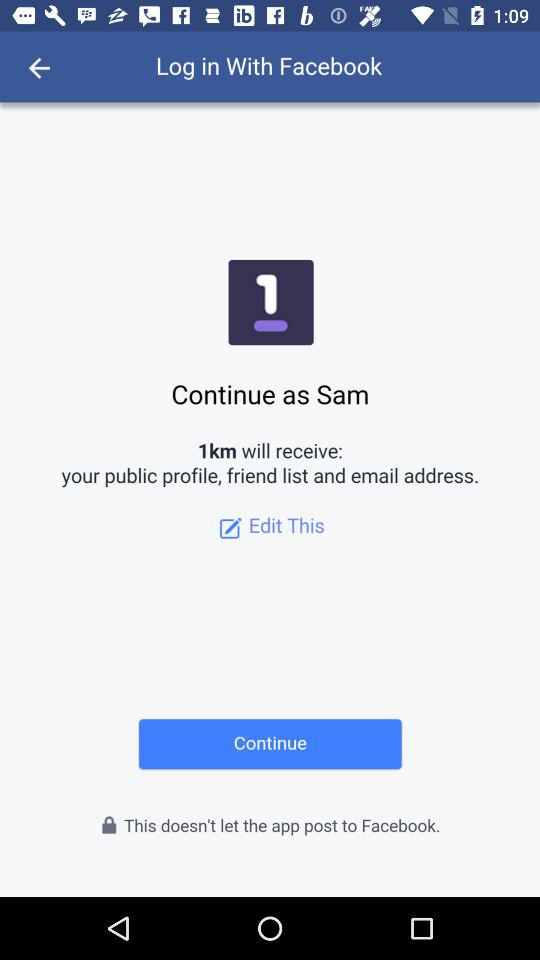What application is asking for permission? The application that is asking for permission is "1km". 